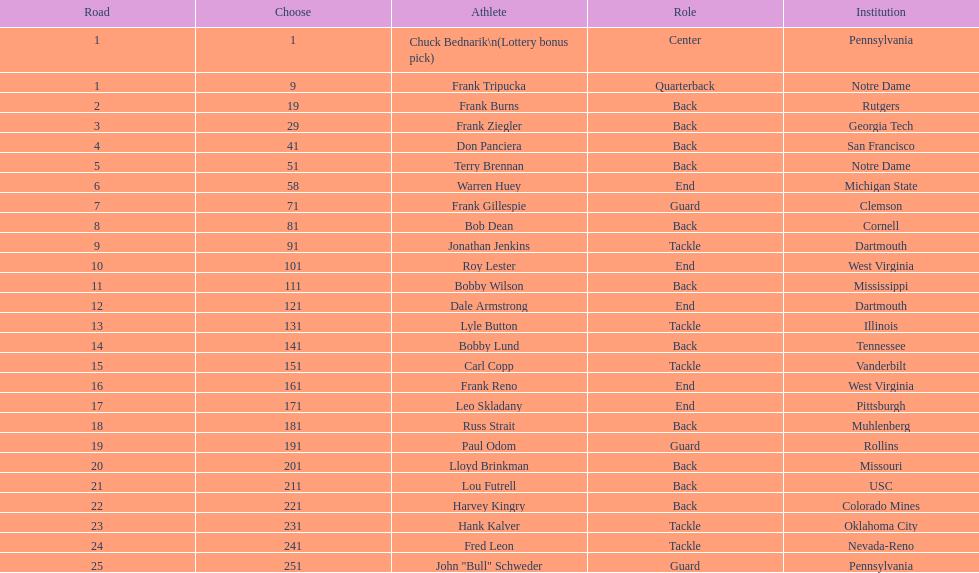Who was picked after frank burns? Frank Ziegler. 